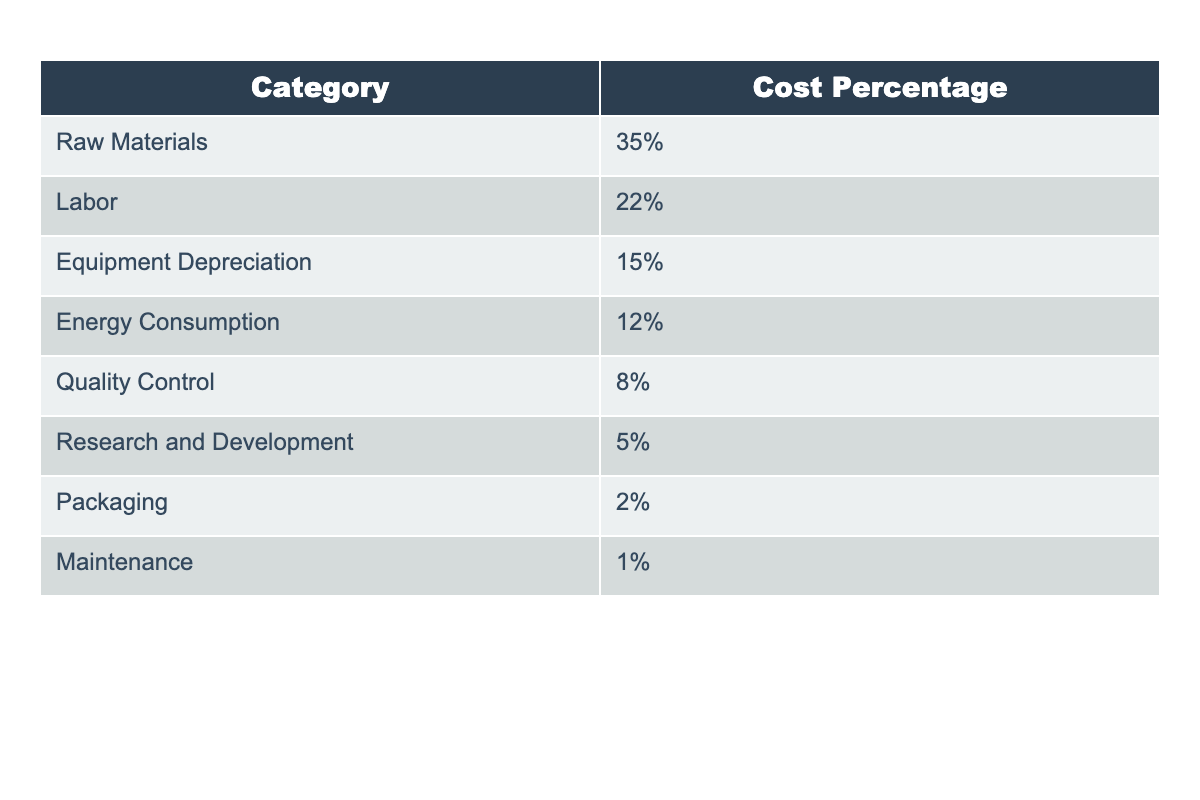What is the percentage of the production cost attributed to raw materials? The table shows the cost breakdown for implementing a new composite material, where the category "Raw Materials" has a listed cost percentage of 35%.
Answer: 35% What is the total percentage of labor and quality control combined? To find the total percentage, I add the values for Labor (22%) and Quality Control (8%). Thus, 22% + 8% = 30%.
Answer: 30% Is energy consumption less than 15% of the total production cost? The table indicates that Energy Consumption is 12%, which is indeed less than 15%. Therefore, the statement is true.
Answer: Yes What percentage of the total production cost is accounted for by packaging and maintenance combined? Packaging accounts for 2% and Maintenance accounts for 1%. Adding these two gives 2% + 1% = 3%.
Answer: 3% Which cost category has the lowest percentage, and what is that percentage? From the table, the category with the lowest percentage is Maintenance, which contributes only 1% to the production cost.
Answer: Maintenance, 1% What is the average percentage of cost for the categories of Research and Development, Packaging, and Maintenance? First, sum the percentages for these three categories: Research and Development (5%), Packaging (2%), and Maintenance (1%), resulting in 5% + 2% + 1% = 8%. Then, divide by the number of categories (3): 8% / 3 = 2.67%.
Answer: 2.67% If we exclude the highest cost category, what will be the total percentage of the remaining categories? The highest cost percentage is for Raw Materials at 35%. Excluding this category, the remaining percentages are 22% for Labor, 15% for Equipment Depreciation, 12% for Energy Consumption, 8% for Quality Control, 5% for Research and Development, 2% for Packaging, and 1% for Maintenance. Summing these gives 22% + 15% + 12% + 8% + 5% + 2% + 1% = 65%.
Answer: 65% Which two categories account for more than 50% of the total costs combined? The categories with the highest contributions are Raw Materials at 35% and Labor at 22%. Adding these gives 35% + 22% = 57%, which is greater than 50%.
Answer: Yes 